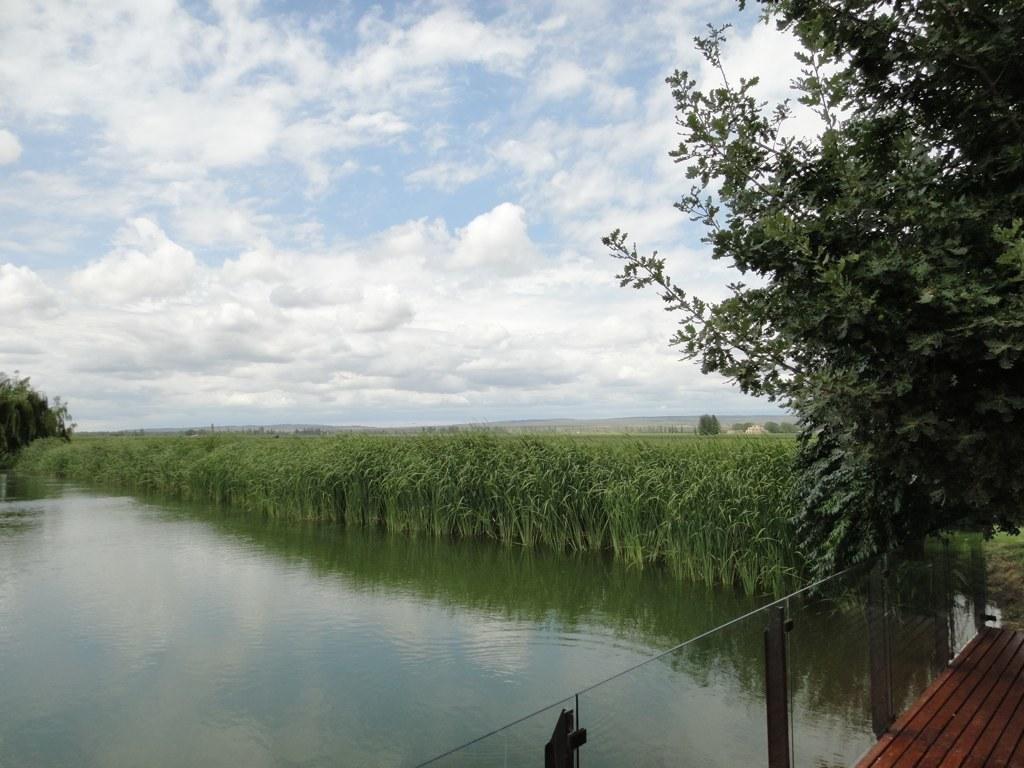What type of natural feature is present in the image? There is a lake in the picture. What type of vegetation can be seen in the image? There are trees and plants in the picture. How would you describe the sky in the image? The sky is cloudy in the picture. What type of industry can be seen in the background of the image? There is no industry present in the image; it features a lake, trees, plants, and a cloudy sky. Can you hear any songs being sung by the trees in the image? Trees do not have the ability to sing songs, and there is no indication of any songs being sung in the image. 